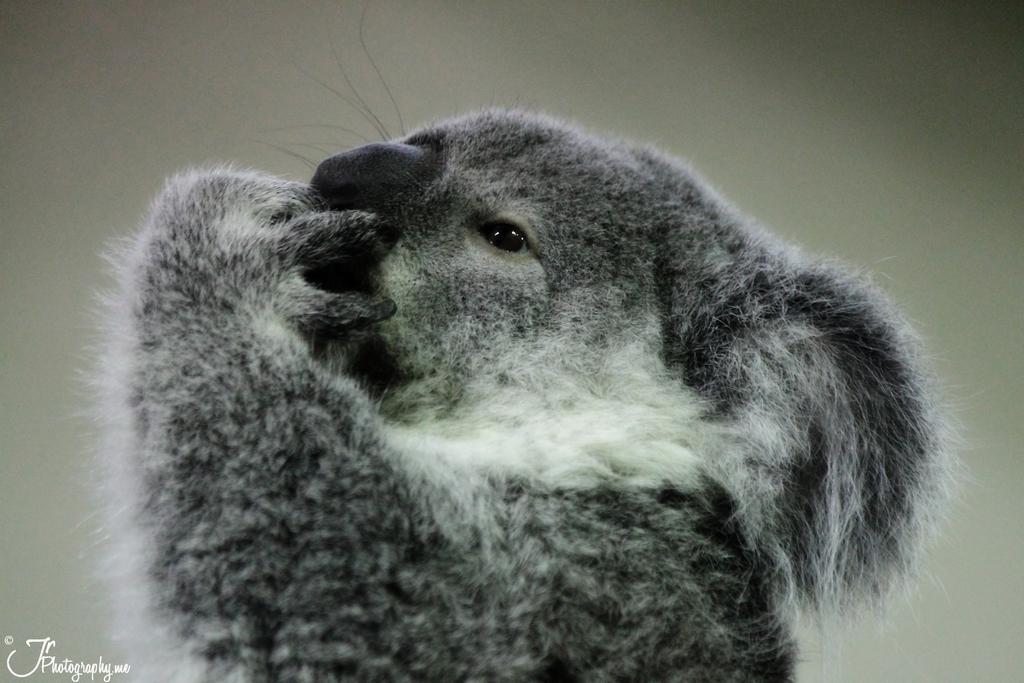In one or two sentences, can you explain what this image depicts? In the picture we can see a koala, which is gray in color with some part white with a fur and keeping the hand near the nose which is black in color. 